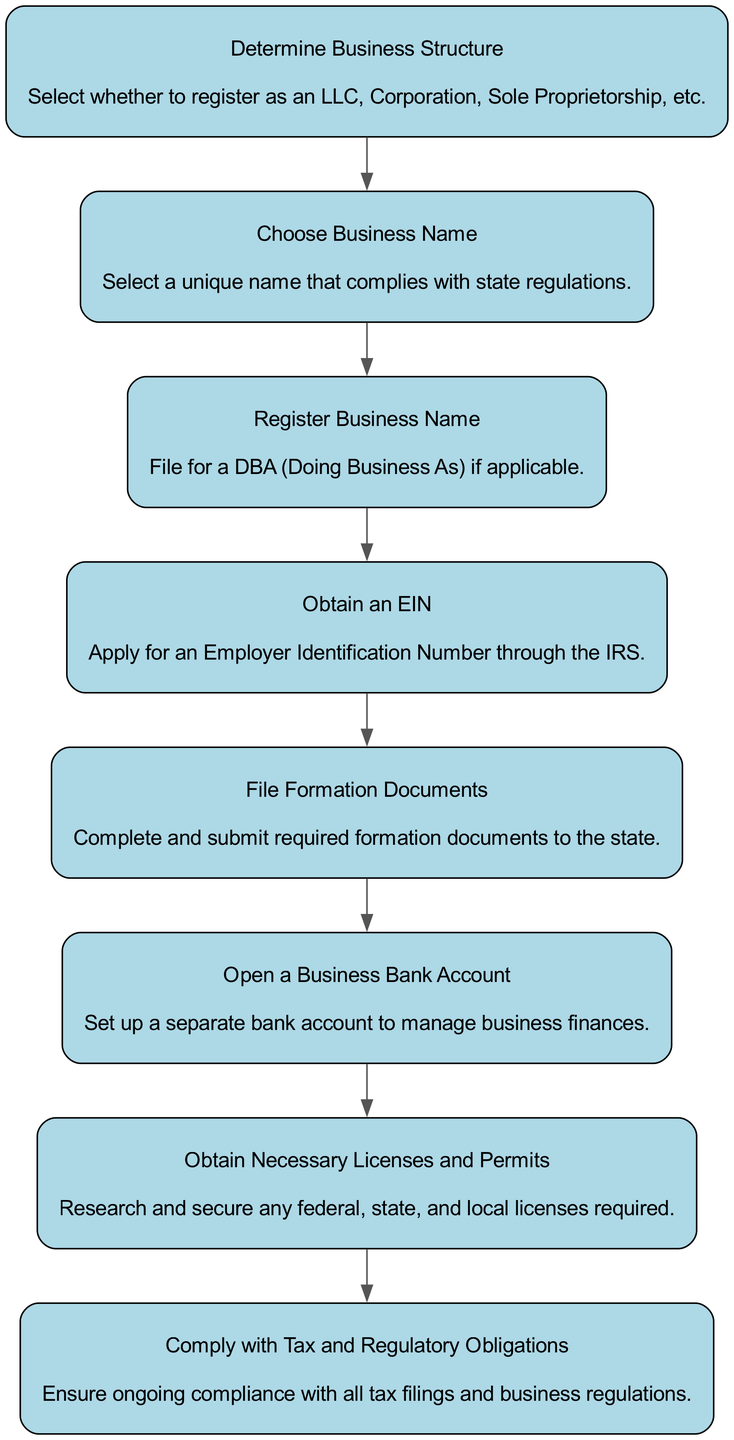What is the first step in the business registration process? The first step is "Determine Business Structure," as it is the first node in the flow chart representing the sequence of actions.
Answer: Determine Business Structure How many nodes are there in the diagram? By counting each unique action in the flow chart, there are 8 nodes representing different steps in the registration process.
Answer: 8 Which two steps are connected directly by an edge in the flow diagram? The edge exists between "Choose Business Name" and "Register Business Name," indicating a direct progression from choosing to registering the name.
Answer: Choose Business Name and Register Business Name What must a business owner obtain after determining the business structure? Following the determination of the business structure, the next step requires obtaining an Employer Identification Number (EIN).
Answer: Obtain an EIN What type of business structure can one choose from? The flow chart mentions several options, specifically LLC, Corporation, and Sole Proprietorship, as possible business structures to register as.
Answer: LLC, Corporation, Sole Proprietorship What is the last step in the business registration process as outlined in the diagram? The final step is "Comply with Tax and Regulatory Obligations," concluding the entire registration process by ensuring ongoing compliance.
Answer: Comply with Tax and Regulatory Obligations How many steps are there before opening a business bank account? There are three preceding steps: "Determine Business Structure," "Choose Business Name," and "Register Business Name" before reaching "Open a Business Bank Account."
Answer: 3 What is necessary to research before obtaining licenses and permits? The diagram indicates that one must research and secure any federal, state, and local licenses required before proceeding with the registration process.
Answer: Federal, state, and local licenses What do steps five and six specifically address in the registration process? Step five, "File Formation Documents," deals with completing and submitting required documents, while step six, "Open a Business Bank Account," focuses on setting up a business account.
Answer: Filing documents and opening a bank account 